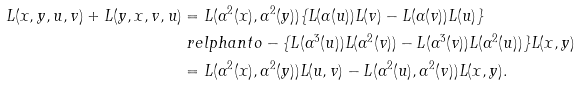<formula> <loc_0><loc_0><loc_500><loc_500>L ( x , y , u , v ) + L ( y , x , v , u ) & = L ( \alpha ^ { 2 } ( x ) , \alpha ^ { 2 } ( y ) ) \{ L ( \alpha ( u ) ) L ( v ) - L ( \alpha ( v ) ) L ( u ) \} \\ & \ r e l p h a n t o - \{ L ( \alpha ^ { 3 } ( u ) ) L ( \alpha ^ { 2 } ( v ) ) - L ( \alpha ^ { 3 } ( v ) ) L ( \alpha ^ { 2 } ( u ) ) \} L ( x , y ) \\ & = L ( \alpha ^ { 2 } ( x ) , \alpha ^ { 2 } ( y ) ) L ( u , v ) - L ( \alpha ^ { 2 } ( u ) , \alpha ^ { 2 } ( v ) ) L ( x , y ) .</formula> 